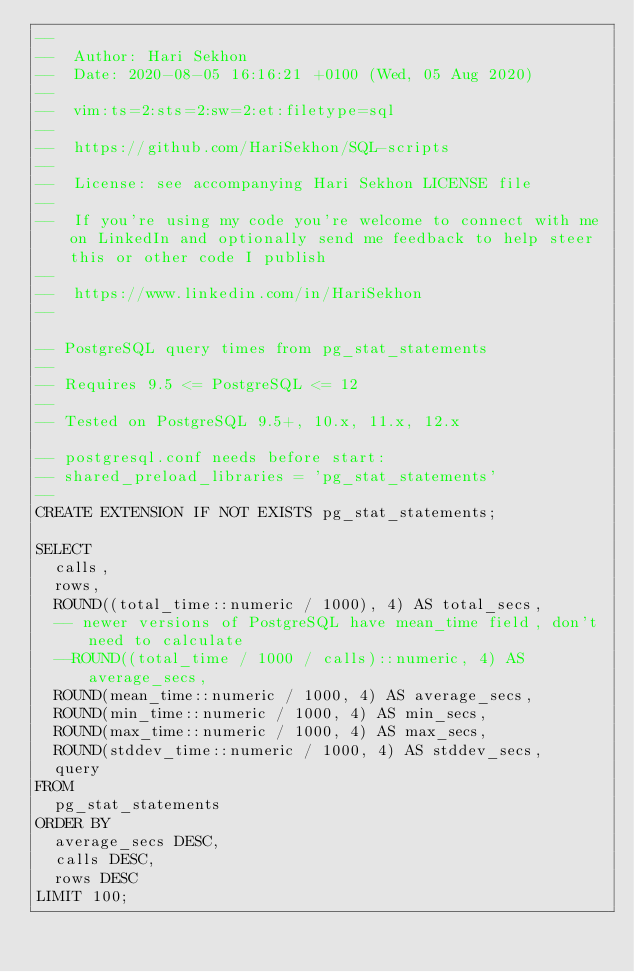Convert code to text. <code><loc_0><loc_0><loc_500><loc_500><_SQL_>--
--  Author: Hari Sekhon
--  Date: 2020-08-05 16:16:21 +0100 (Wed, 05 Aug 2020)
--
--  vim:ts=2:sts=2:sw=2:et:filetype=sql
--
--  https://github.com/HariSekhon/SQL-scripts
--
--  License: see accompanying Hari Sekhon LICENSE file
--
--  If you're using my code you're welcome to connect with me on LinkedIn and optionally send me feedback to help steer this or other code I publish
--
--  https://www.linkedin.com/in/HariSekhon
--

-- PostgreSQL query times from pg_stat_statements
--
-- Requires 9.5 <= PostgreSQL <= 12
--
-- Tested on PostgreSQL 9.5+, 10.x, 11.x, 12.x

-- postgresql.conf needs before start:
-- shared_preload_libraries = 'pg_stat_statements'
--
CREATE EXTENSION IF NOT EXISTS pg_stat_statements;

SELECT
  calls,
  rows,
  ROUND((total_time::numeric / 1000), 4) AS total_secs,
  -- newer versions of PostgreSQL have mean_time field, don't need to calculate
  --ROUND((total_time / 1000 / calls)::numeric, 4) AS average_secs,
  ROUND(mean_time::numeric / 1000, 4) AS average_secs,
  ROUND(min_time::numeric / 1000, 4) AS min_secs,
  ROUND(max_time::numeric / 1000, 4) AS max_secs,
  ROUND(stddev_time::numeric / 1000, 4) AS stddev_secs,
  query
FROM
  pg_stat_statements
ORDER BY
  average_secs DESC,
  calls DESC,
  rows DESC
LIMIT 100;
</code> 